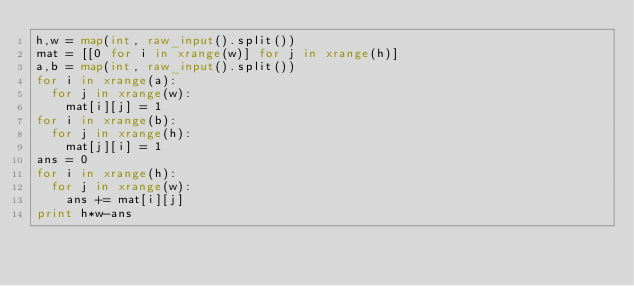<code> <loc_0><loc_0><loc_500><loc_500><_Python_>h,w = map(int, raw_input().split())
mat = [[0 for i in xrange(w)] for j in xrange(h)]
a,b = map(int, raw_input().split())
for i in xrange(a):
	for j in xrange(w):
		mat[i][j] = 1
for i in xrange(b):
	for j in xrange(h):
		mat[j][i] = 1
ans = 0
for i in xrange(h):
	for j in xrange(w):
		ans += mat[i][j]
print h*w-ans</code> 